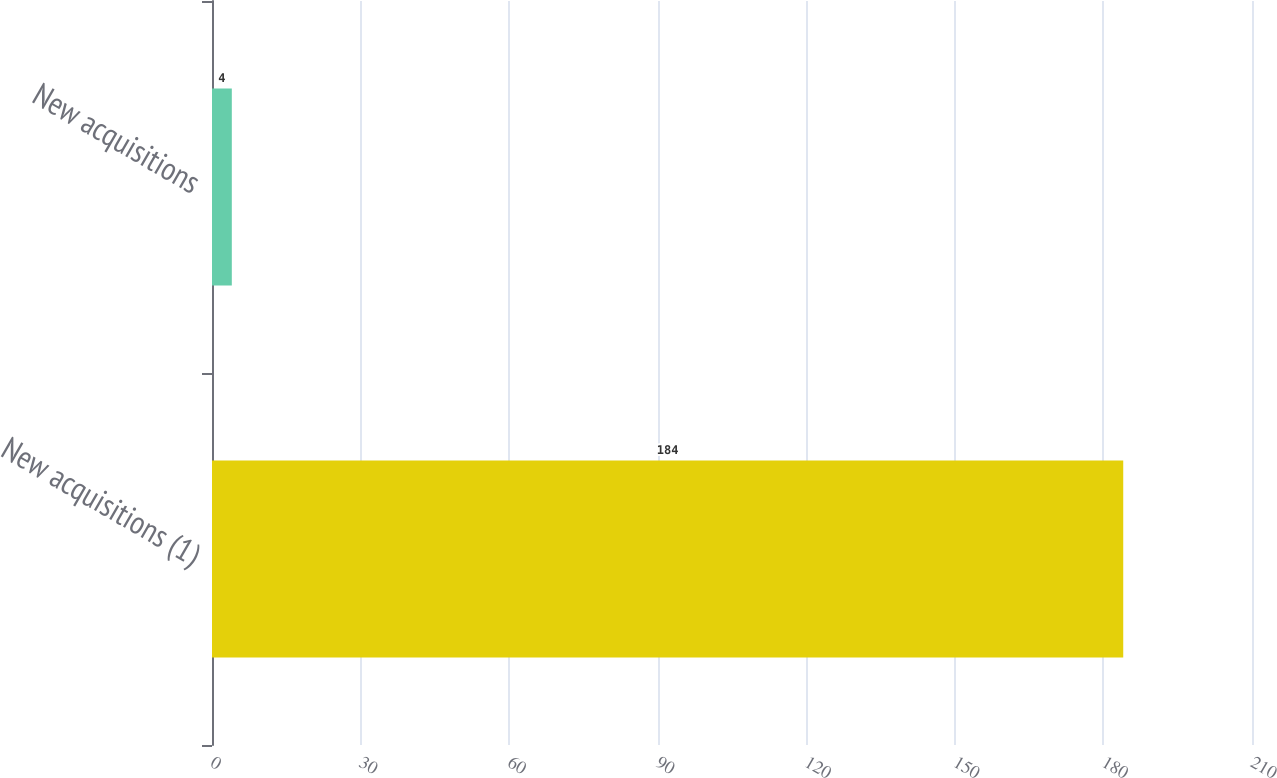Convert chart to OTSL. <chart><loc_0><loc_0><loc_500><loc_500><bar_chart><fcel>New acquisitions (1)<fcel>New acquisitions<nl><fcel>184<fcel>4<nl></chart> 